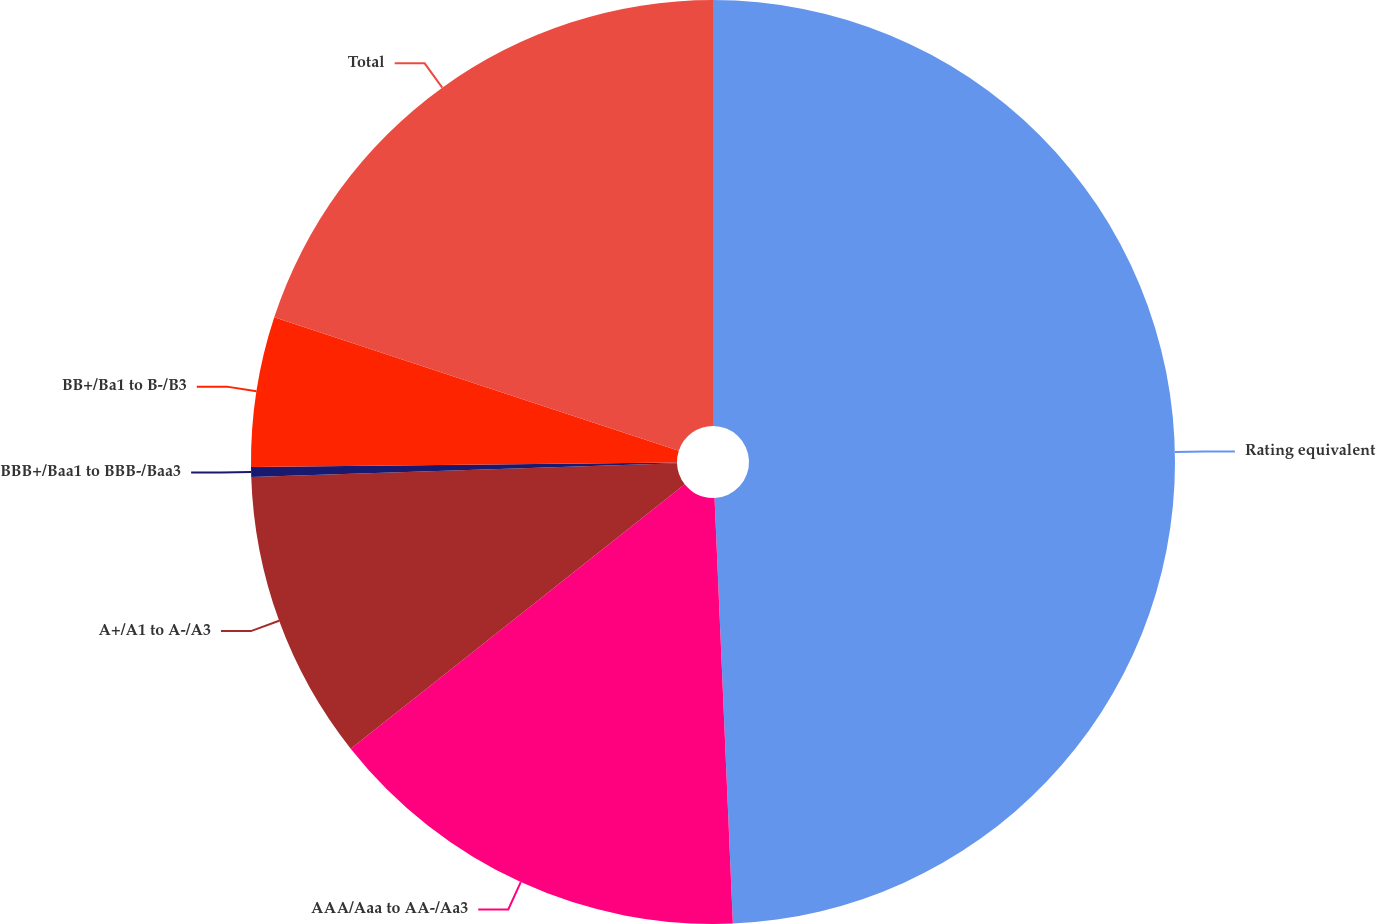Convert chart to OTSL. <chart><loc_0><loc_0><loc_500><loc_500><pie_chart><fcel>Rating equivalent<fcel>AAA/Aaa to AA-/Aa3<fcel>A+/A1 to A-/A3<fcel>BBB+/Baa1 to BBB-/Baa3<fcel>BB+/Ba1 to B-/B3<fcel>Total<nl><fcel>49.31%<fcel>15.03%<fcel>10.14%<fcel>0.34%<fcel>5.24%<fcel>19.93%<nl></chart> 